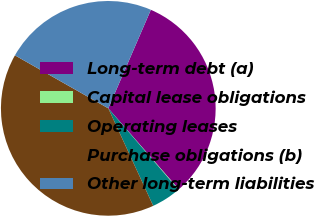Convert chart to OTSL. <chart><loc_0><loc_0><loc_500><loc_500><pie_chart><fcel>Long-term debt (a)<fcel>Capital lease obligations<fcel>Operating leases<fcel>Purchase obligations (b)<fcel>Other long-term liabilities<nl><fcel>32.11%<fcel>0.08%<fcel>4.45%<fcel>40.09%<fcel>23.27%<nl></chart> 